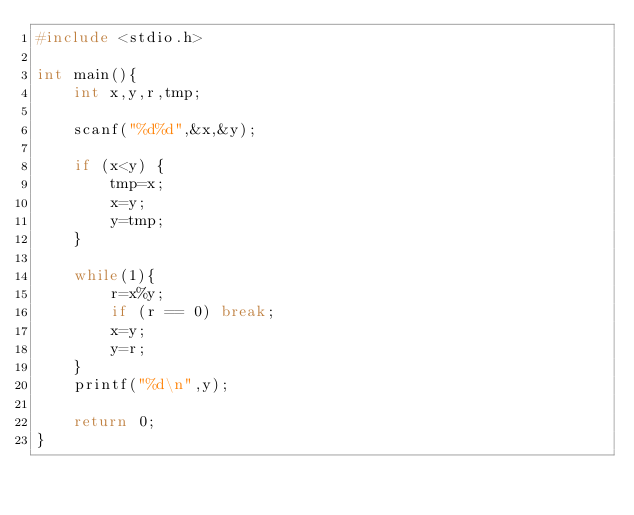Convert code to text. <code><loc_0><loc_0><loc_500><loc_500><_C_>#include <stdio.h>

int main(){
    int x,y,r,tmp;

    scanf("%d%d",&x,&y);

    if (x<y) {
        tmp=x;
        x=y;
        y=tmp;
    }

    while(1){
        r=x%y;
        if (r == 0) break;
        x=y;
        y=r;
    }
    printf("%d\n",y);

    return 0;
}

</code> 